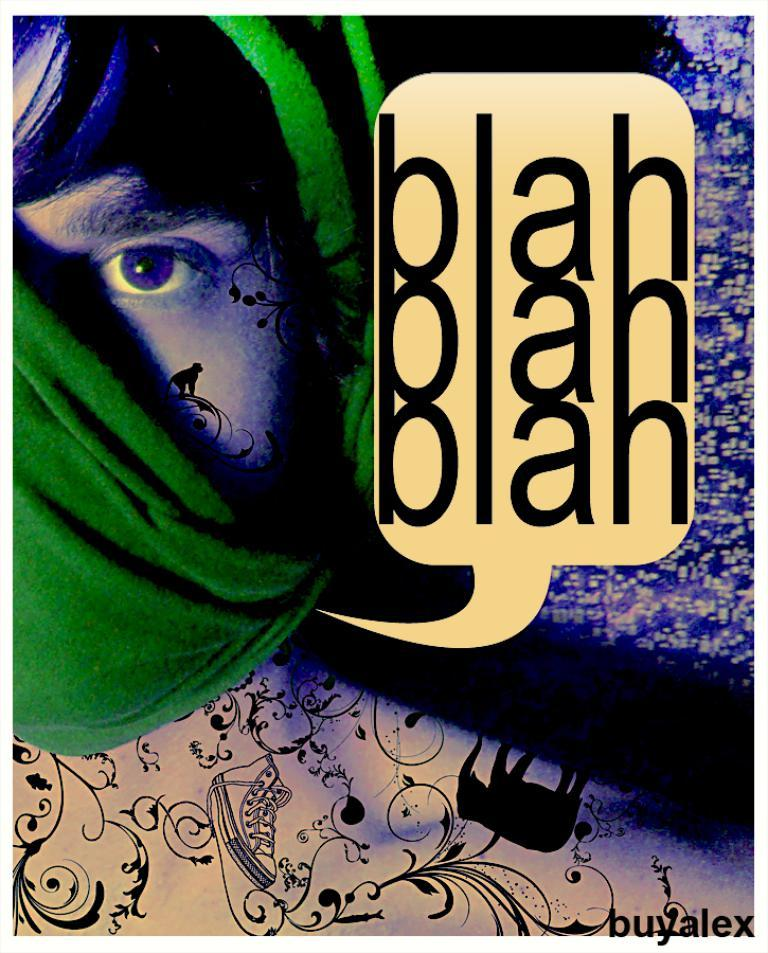Who is present in the image? There is a man in the image. What else can be seen in the image besides the man? There is text and a cartoon elephant in the image. What type of patch is visible on the man's clothing in the image? There is no patch visible on the man's clothing in the image. 